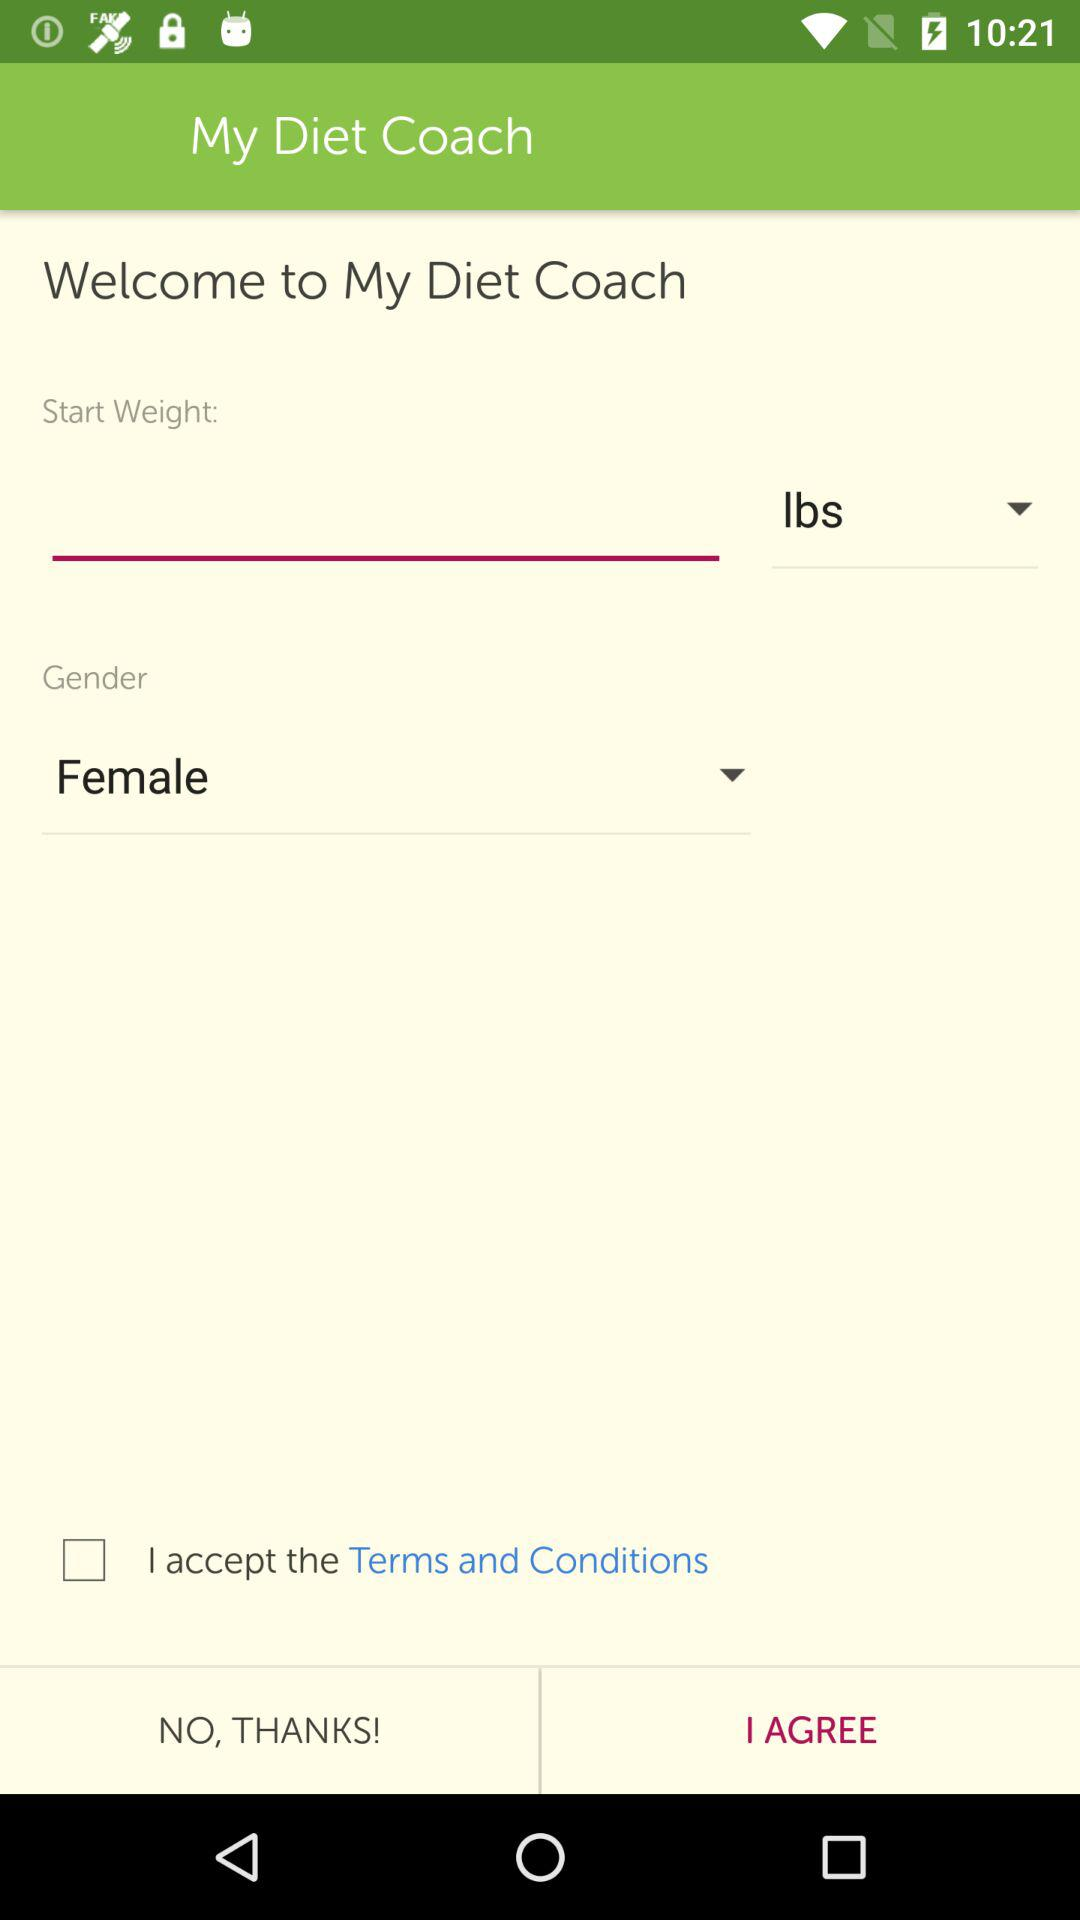What is the status of "I accept the Terms and Conditions"? The status is "off". 